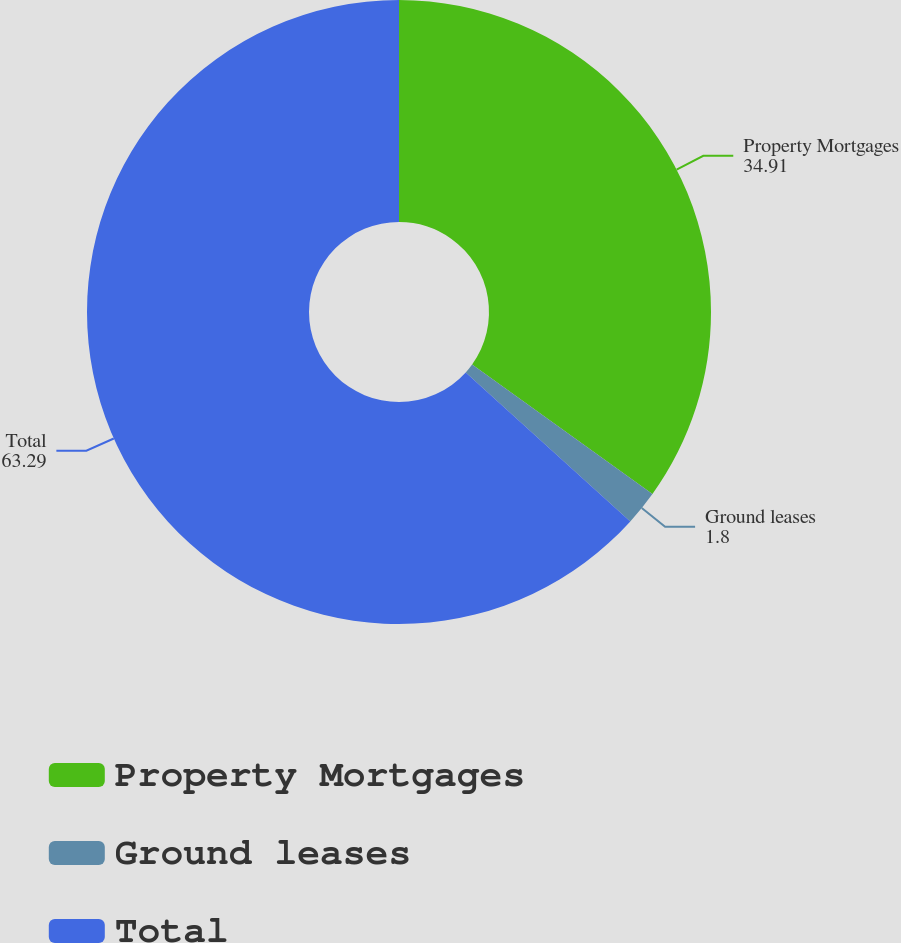Convert chart. <chart><loc_0><loc_0><loc_500><loc_500><pie_chart><fcel>Property Mortgages<fcel>Ground leases<fcel>Total<nl><fcel>34.91%<fcel>1.8%<fcel>63.29%<nl></chart> 